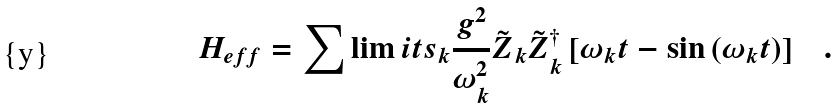Convert formula to latex. <formula><loc_0><loc_0><loc_500><loc_500>H _ { e f f } = \sum \lim i t s _ { k } { \frac { g ^ { 2 } } { \omega _ { k } ^ { 2 } } { \tilde { Z } } _ { k } { \tilde { Z } } _ { k } ^ { \dagger } \left [ { \omega _ { k } t - \sin \left ( { \omega _ { k } t } \right ) } \right ] } \quad .</formula> 